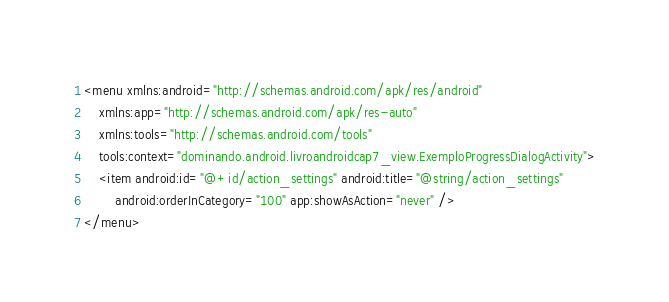<code> <loc_0><loc_0><loc_500><loc_500><_XML_><menu xmlns:android="http://schemas.android.com/apk/res/android"
    xmlns:app="http://schemas.android.com/apk/res-auto"
    xmlns:tools="http://schemas.android.com/tools"
    tools:context="dominando.android.livroandroidcap7_view.ExemploProgressDialogActivity">
    <item android:id="@+id/action_settings" android:title="@string/action_settings"
        android:orderInCategory="100" app:showAsAction="never" />
</menu>
</code> 